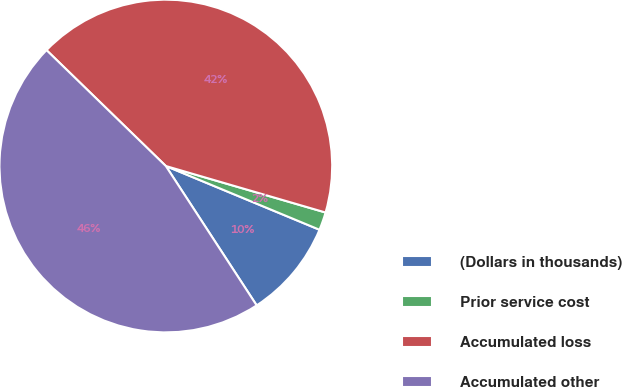Convert chart to OTSL. <chart><loc_0><loc_0><loc_500><loc_500><pie_chart><fcel>(Dollars in thousands)<fcel>Prior service cost<fcel>Accumulated loss<fcel>Accumulated other<nl><fcel>9.55%<fcel>1.75%<fcel>42.24%<fcel>46.46%<nl></chart> 